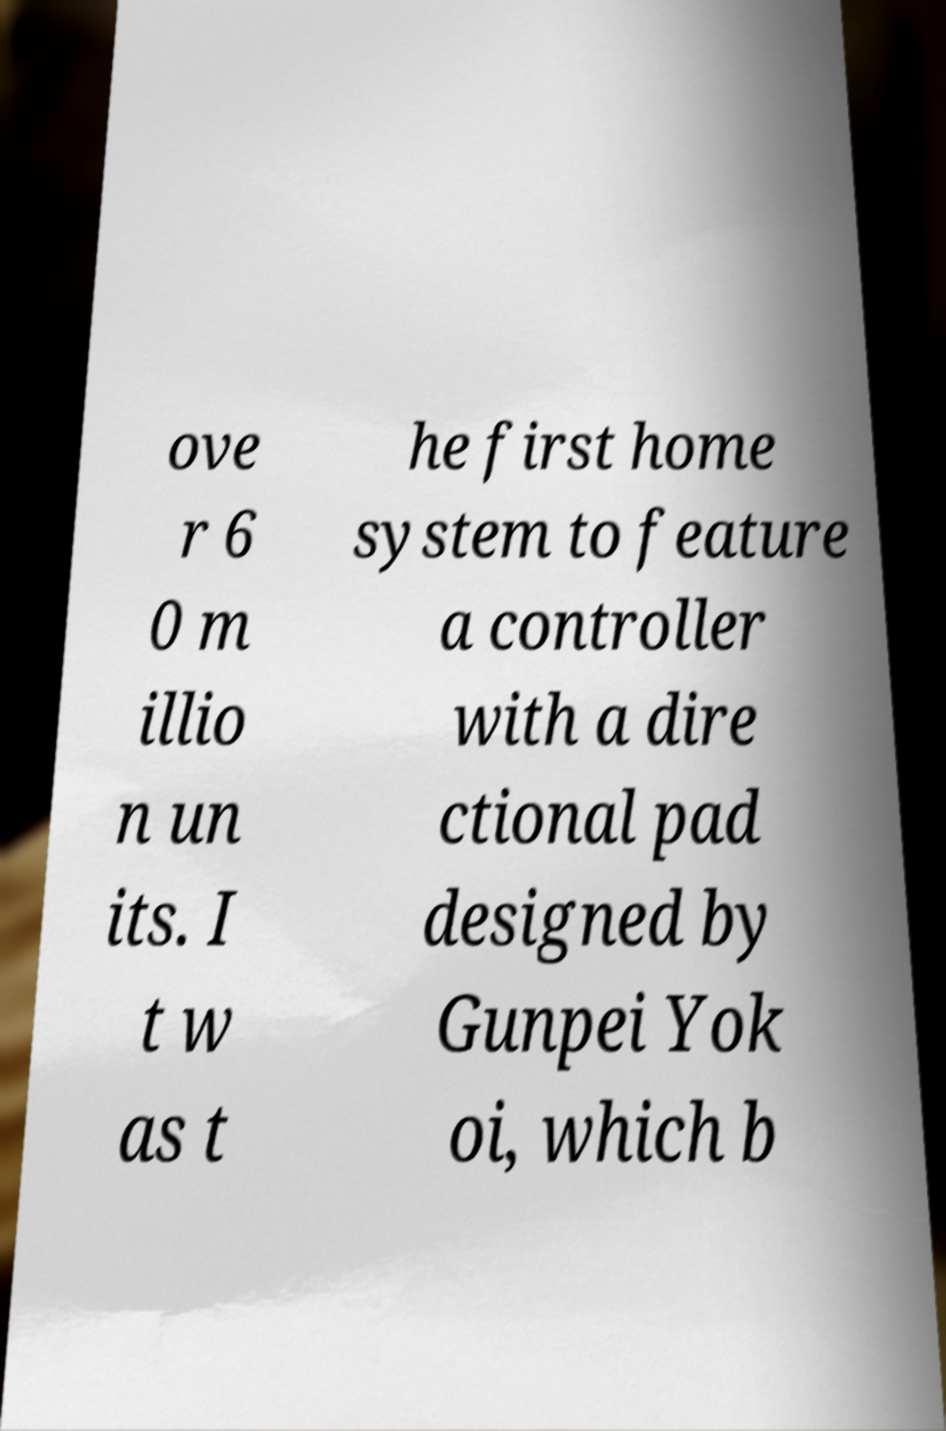There's text embedded in this image that I need extracted. Can you transcribe it verbatim? ove r 6 0 m illio n un its. I t w as t he first home system to feature a controller with a dire ctional pad designed by Gunpei Yok oi, which b 